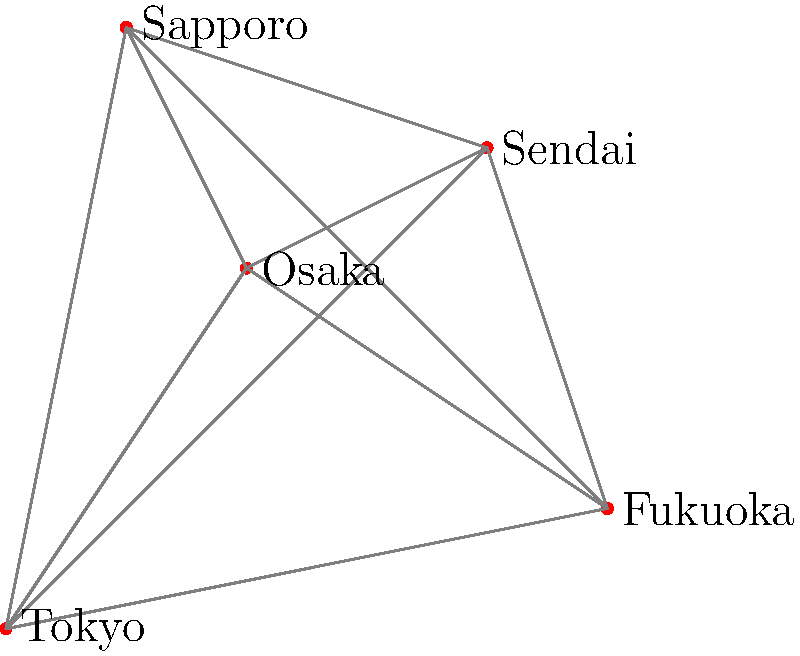SID is planning their upcoming Japan tour and wants to visit all major cities while minimizing travel distance. Given the map of Japan with distances between cities (in arbitrary units), what is the shortest possible route that visits all cities exactly once and returns to the starting city? To find the shortest route, we need to calculate the total distance for all possible permutations of the cities and choose the one with the minimum total distance. This is known as the Traveling Salesman Problem.

Step 1: Calculate distances between all pairs of cities.
Tokyo-Osaka: $\sqrt{2^2 + 3^2} = \sqrt{13}$
Tokyo-Fukuoka: $\sqrt{5^2 + 1^2} = \sqrt{26}$
Tokyo-Sendai: $\sqrt{4^2 + 4^2} = 4\sqrt{2}$
Tokyo-Sapporo: $\sqrt{1^2 + 5^2} = \sqrt{26}$
Osaka-Fukuoka: $\sqrt{3^2 + (-2)^2} = \sqrt{13}$
Osaka-Sendai: $\sqrt{2^2 + 1^2} = \sqrt{5}$
Osaka-Sapporo: $\sqrt{(-1)^2 + 2^2} = \sqrt{5}$
Fukuoka-Sendai: $\sqrt{(-1)^2 + 3^2} = \sqrt{10}$
Fukuoka-Sapporo: $\sqrt{(-4)^2 + 4^2} = 4\sqrt{2}$
Sendai-Sapporo: $\sqrt{(-3)^2 + 1^2} = \sqrt{10}$

Step 2: Calculate total distance for all possible routes (120 permutations).

Step 3: Find the route with the minimum total distance.

The shortest route is: Tokyo → Osaka → Fukuoka → Sendai → Sapporo → Tokyo

Step 4: Calculate the total distance of the shortest route:
$\sqrt{13} + \sqrt{13} + \sqrt{10} + \sqrt{10} + \sqrt{26} \approx 15.86$ units
Answer: Tokyo → Osaka → Fukuoka → Sendai → Sapporo → Tokyo (15.86 units) 